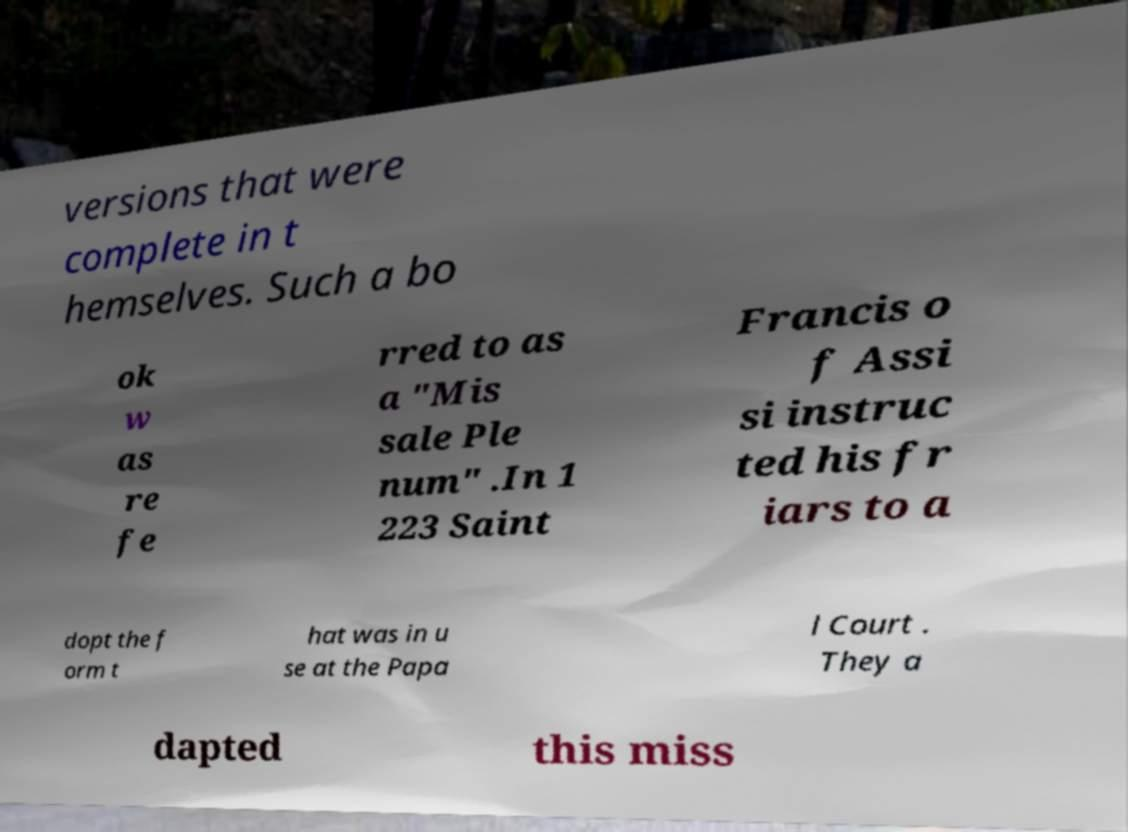Please read and relay the text visible in this image. What does it say? versions that were complete in t hemselves. Such a bo ok w as re fe rred to as a "Mis sale Ple num" .In 1 223 Saint Francis o f Assi si instruc ted his fr iars to a dopt the f orm t hat was in u se at the Papa l Court . They a dapted this miss 